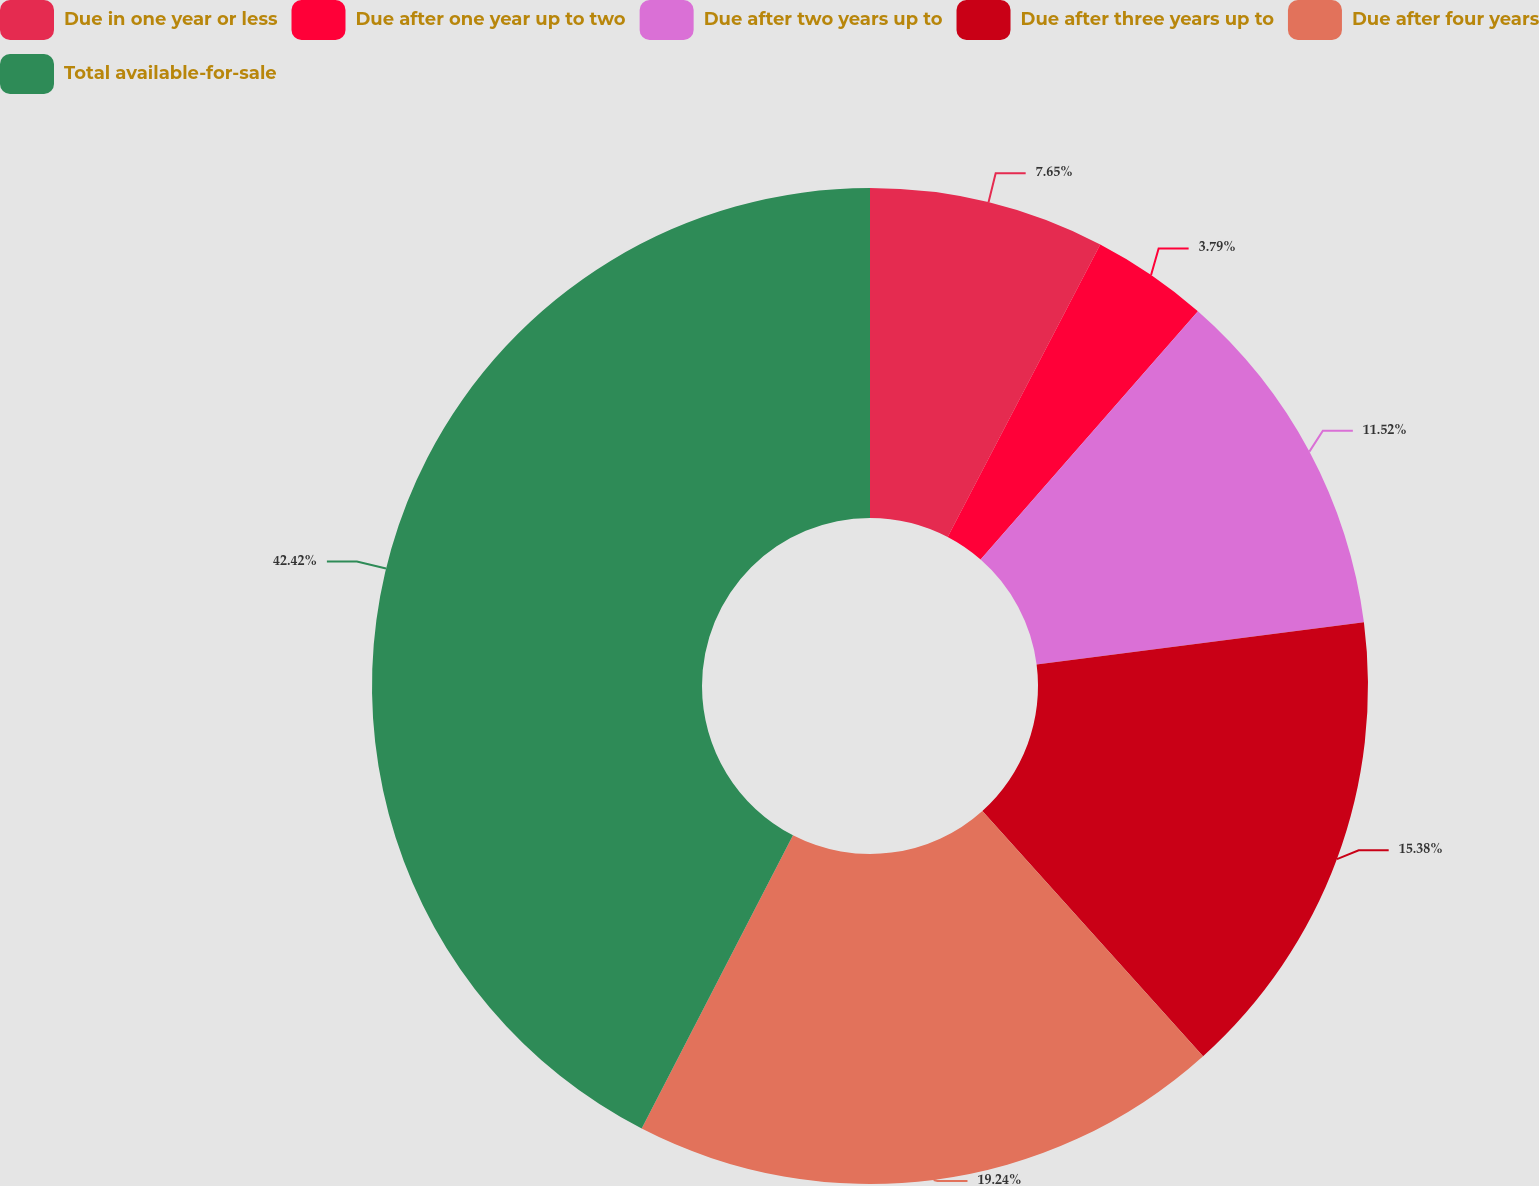Convert chart to OTSL. <chart><loc_0><loc_0><loc_500><loc_500><pie_chart><fcel>Due in one year or less<fcel>Due after one year up to two<fcel>Due after two years up to<fcel>Due after three years up to<fcel>Due after four years<fcel>Total available-for-sale<nl><fcel>7.65%<fcel>3.79%<fcel>11.52%<fcel>15.38%<fcel>19.24%<fcel>42.42%<nl></chart> 